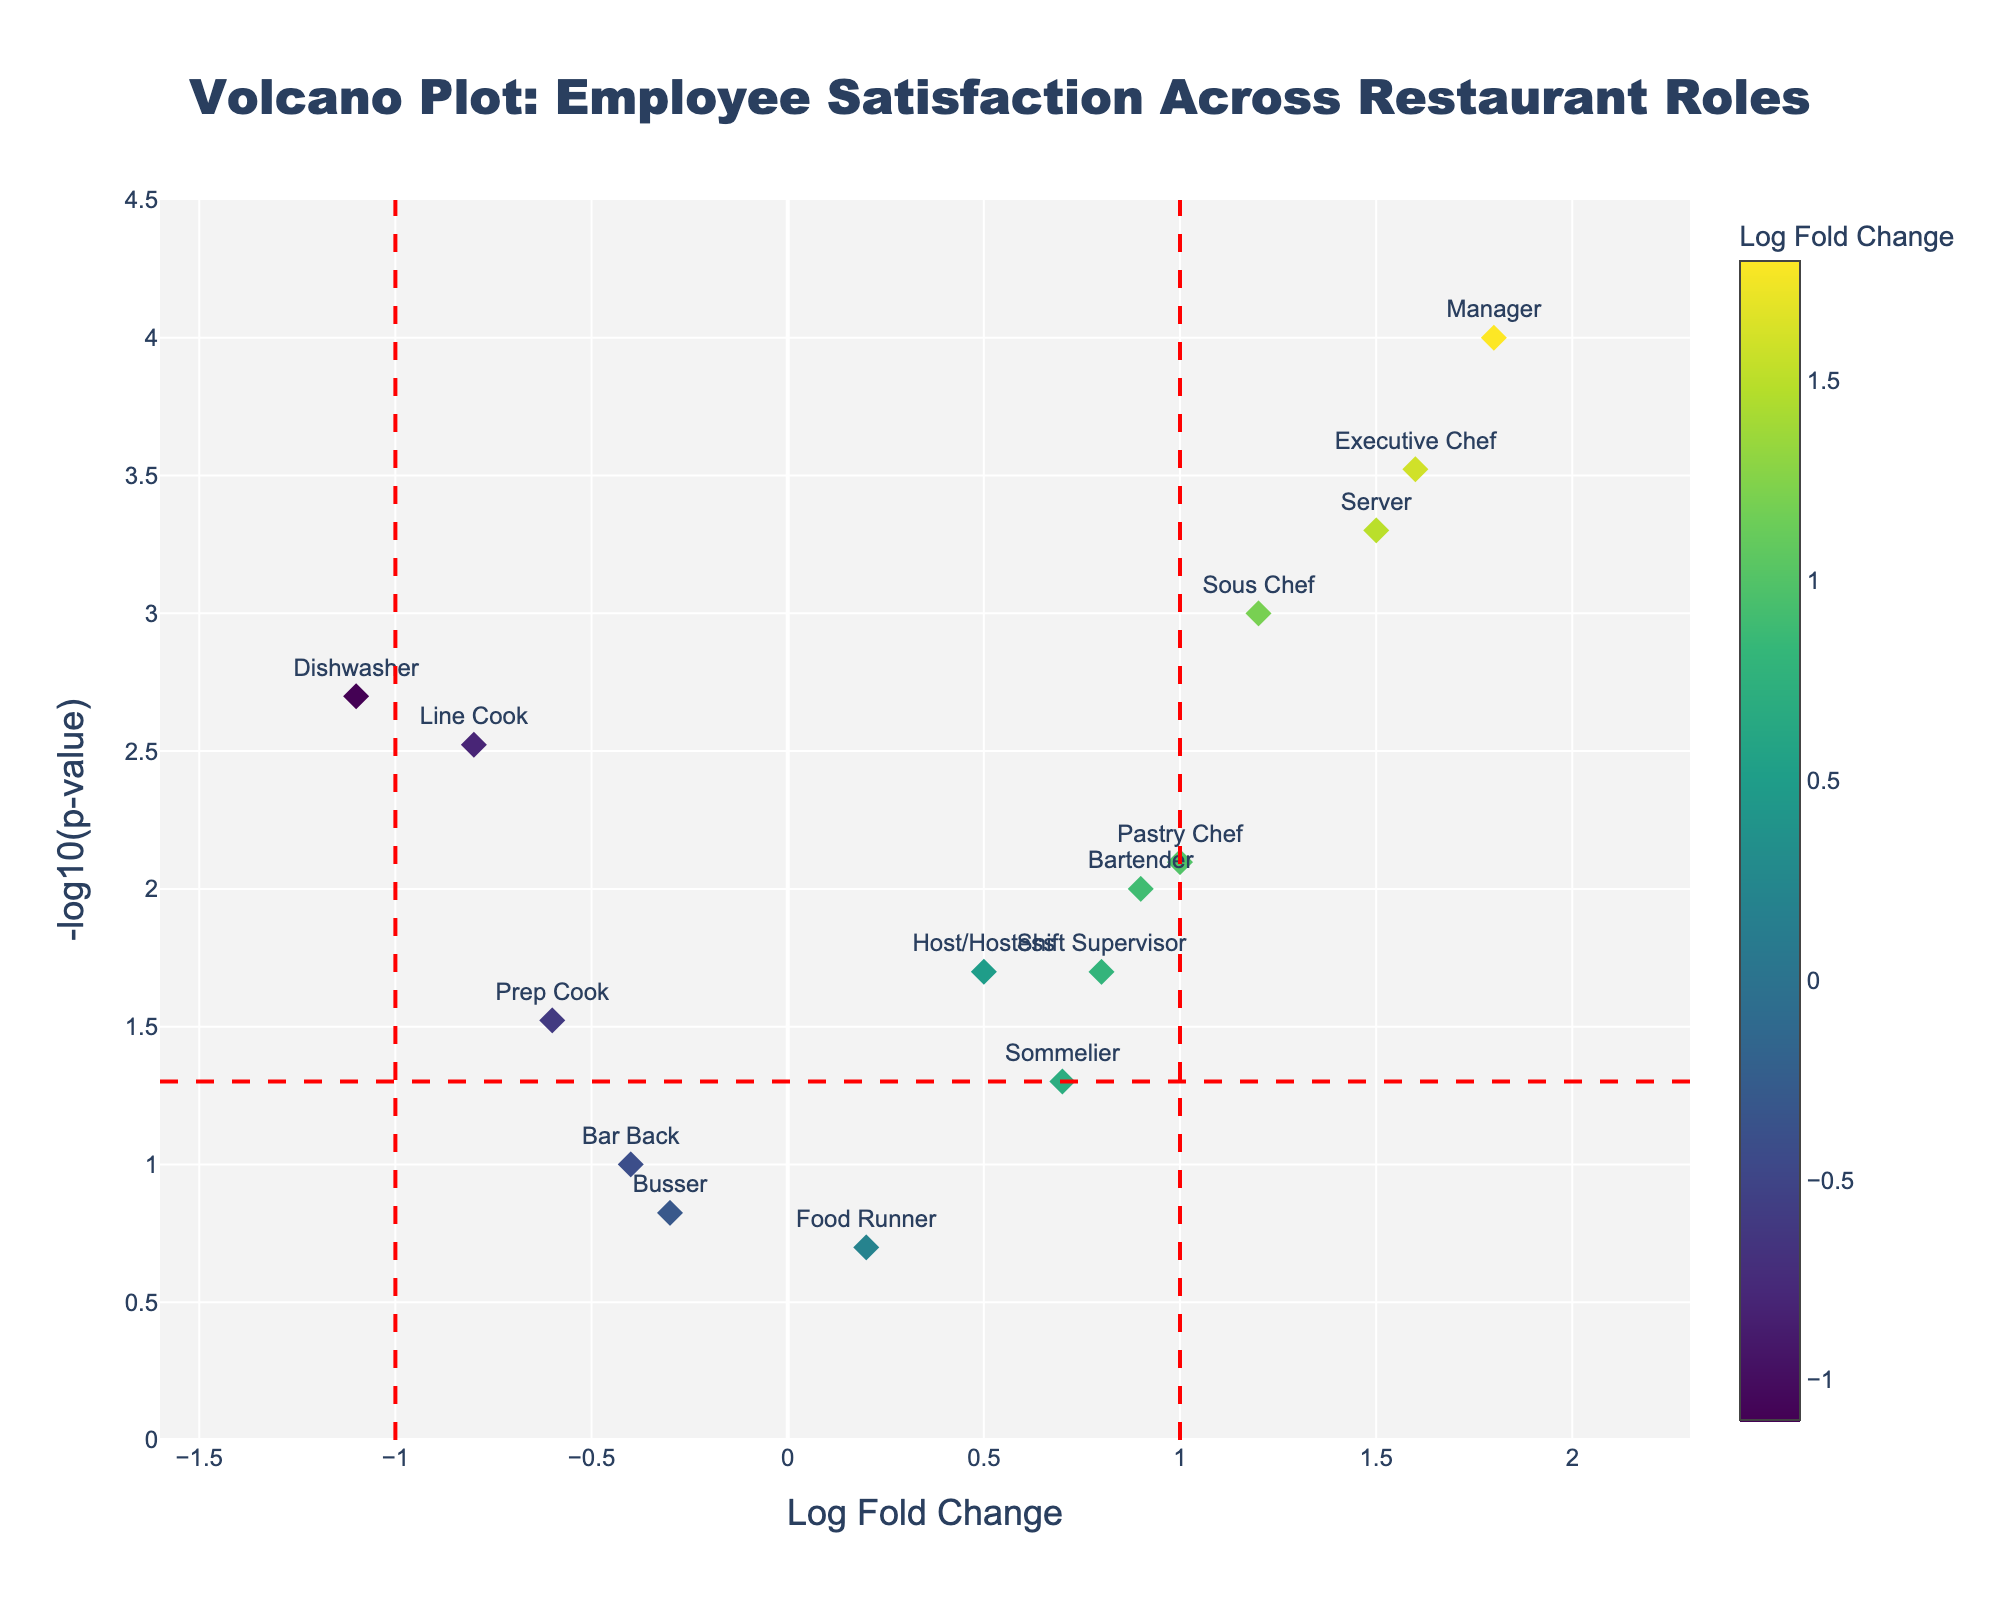what is the x-axis title? The x-axis shows the "Log Fold Change", where positive values indicate higher satisfaction and negative values indicate lower satisfaction.
Answer: Log Fold Change What role shows the highest satisfaction? The role with the highest satisfaction has the highest Log Fold Change. By looking at the figure, the Manager role has the highest Log Fold Change.
Answer: Manager Which roles have a statistically significant increase in satisfaction? In the volcano plot, statistically significant points are above the horizontal red dashed line (p-value < 0.05) and to the right of the vertical red dashed line (Log Fold Change > 1). The roles are Sous Chef, Server, Manager, Pastry Chef, and Executive Chef.
Answer: Sous Chef, Server, Manager, Pastry Chef, Executive Chef How many roles show a statistically significant decrease in satisfaction? Statistically significant decreases are indicated by points above the horizontal red dashed line (p-value < 0.05) and to the left of the vertical red dashed line (Log Fold Change < -1). The Dishwasher role meets this criteria.
Answer: 1 What is the significance cutoff for p-value in this figure? The p-value cutoff for statistical significance is shown as a red dashed horizontal line at -log10(0.05).
Answer: 0.05 What is the Log Fold Change for the Bartender role? Find the Bartender label on the x-axis of the volcano plot to determine its Log Fold Change value, which is around 0.9.
Answer: 0.9 Which role has the lowest p-value? The role with the lowest p-value will appear the highest on the y-axis of the volcano plot. The Manager role is at the highest position.
Answer: Manager Compare the Log Fold Change between the Server and Line Cook roles. Which has a higher satisfaction change? By looking at the plot, the Server has a Log Fold Change of 1.5 while the Line Cook has a Log Fold Change of -0.8. The Server role has a higher satisfaction change.
Answer: Server How is the Pastry Chef role labeled according to the p-value significance? The Pastry Chef role has a statistically significant change, which is indicated by it being above the red horizontal dashed line (p-value < 0.05) with a Log Fold Change of 1.0.
Answer: Statistically significant How many roles have a Log Fold Change greater than zero? Count the roles to the right of the vertical red dashed line (Log Fold Change > 0). There are 10 such roles.
Answer: 10 